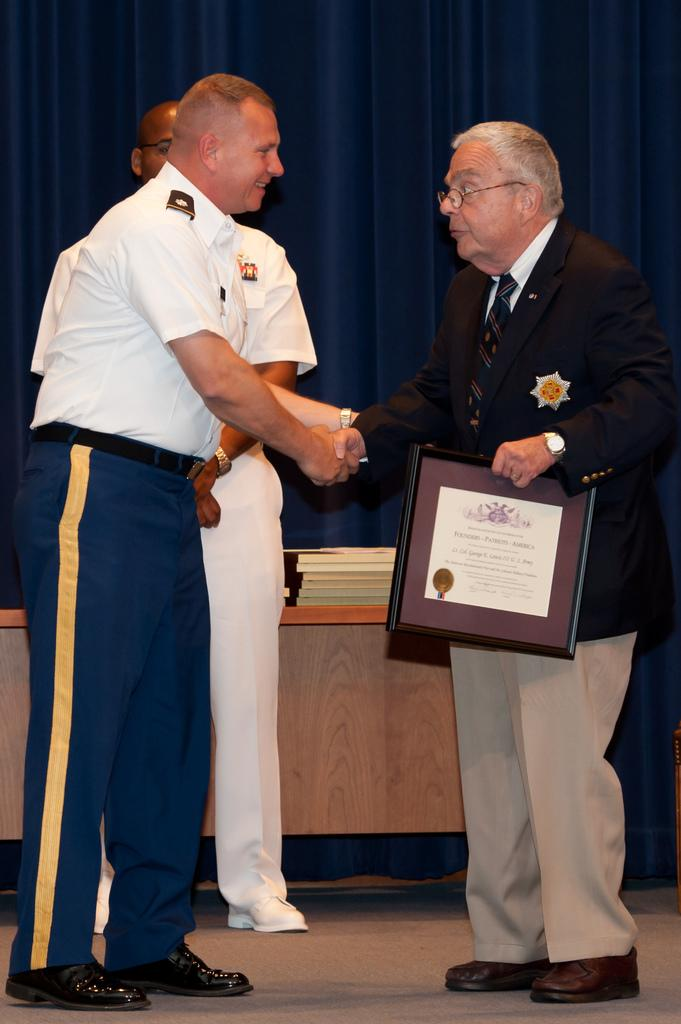What are the people in the image doing? The people in the image are standing. What is one person holding in the image? One person is holding a frame. What can be seen in the background of the image? There is a table in the background. What is on the table in the image? There are books on the table. What type of material is visible at the top of the image? There is cloth visible at the top of the image. What is the rate of the pear falling from the tree in the image? There is no pear or tree present in the image, so it is not possible to determine a rate of falling. 